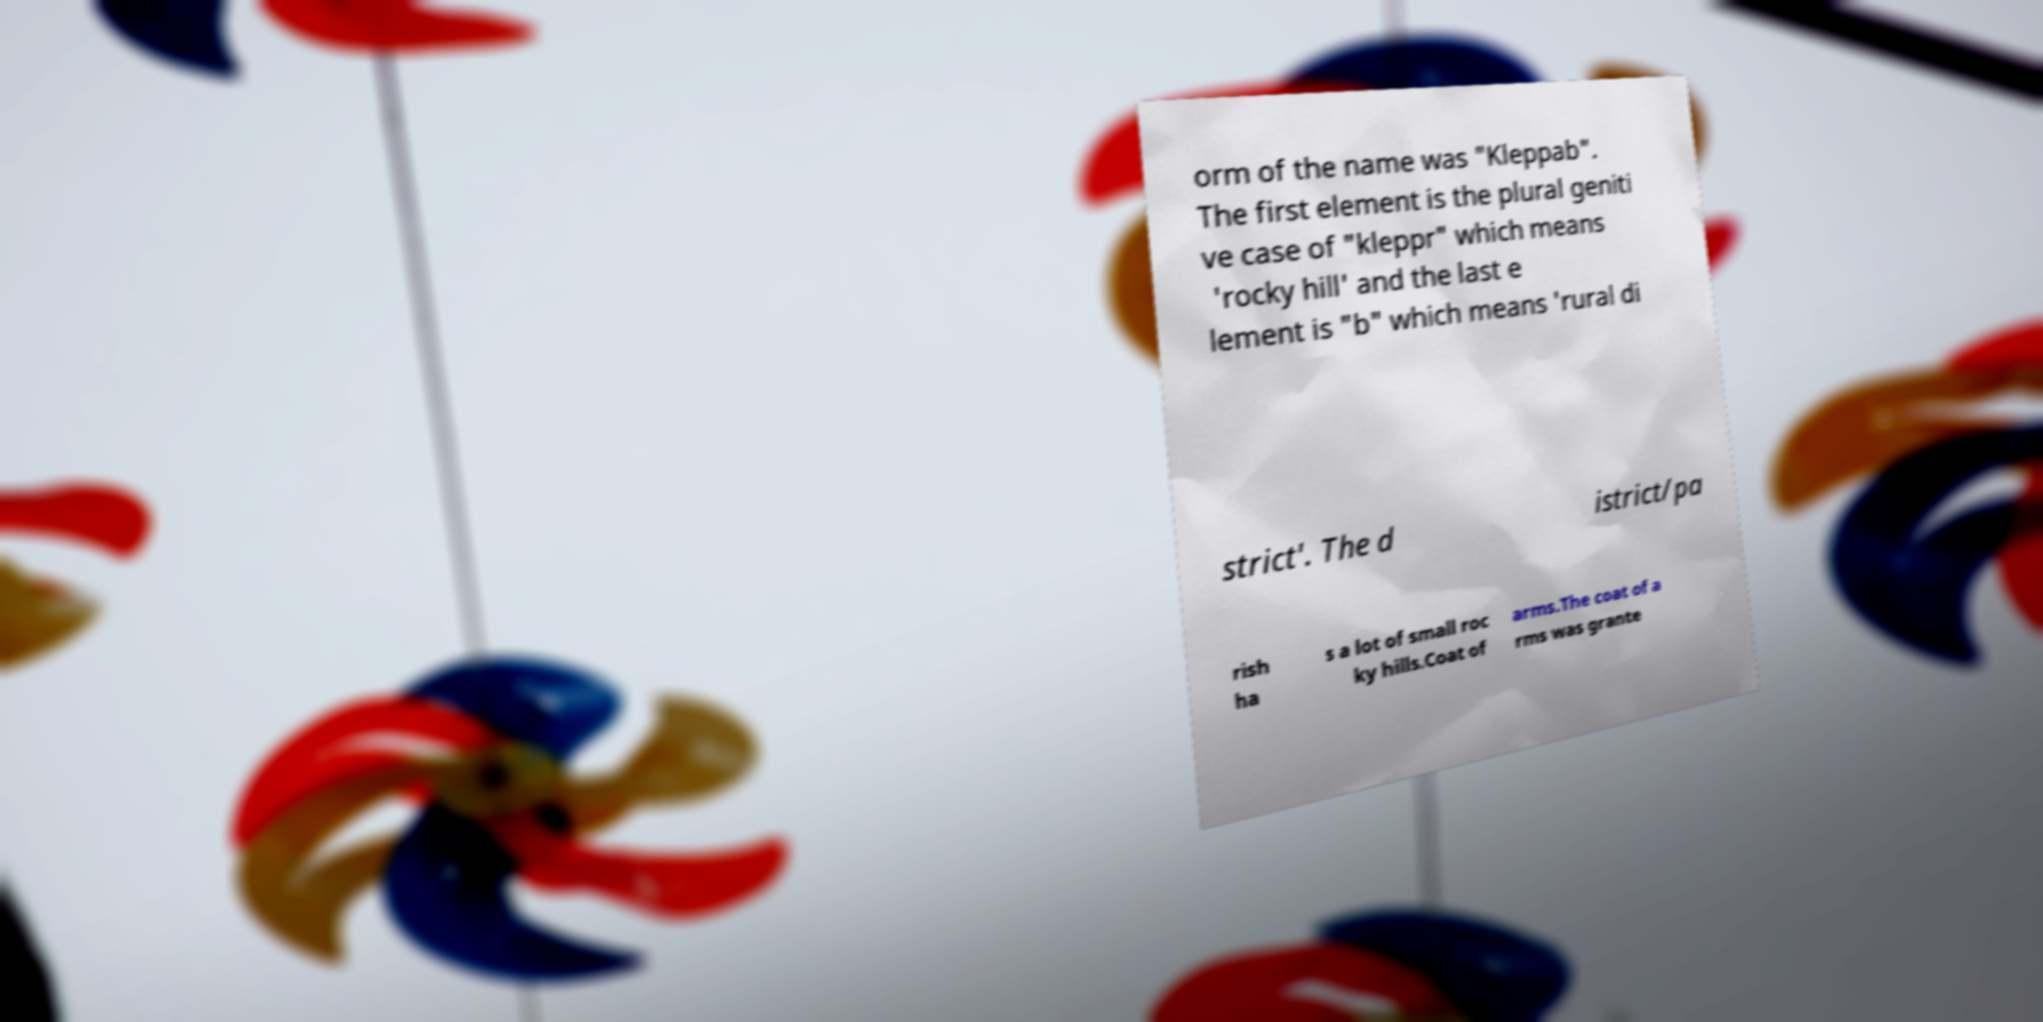Could you extract and type out the text from this image? orm of the name was "Kleppab". The first element is the plural geniti ve case of "kleppr" which means 'rocky hill' and the last e lement is "b" which means 'rural di strict'. The d istrict/pa rish ha s a lot of small roc ky hills.Coat of arms.The coat of a rms was grante 